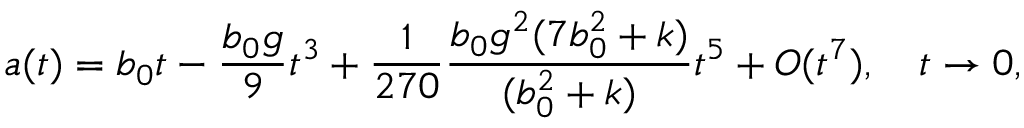<formula> <loc_0><loc_0><loc_500><loc_500>a ( t ) = b _ { 0 } t - \frac { b _ { 0 } g } { 9 } t ^ { 3 } + \frac { 1 } { 2 7 0 } \frac { b _ { 0 } g ^ { 2 } ( 7 b _ { 0 } ^ { 2 } + k ) } { ( b _ { 0 } ^ { 2 } + k ) } t ^ { 5 } + O ( t ^ { 7 } ) , \quad t \to 0 ,</formula> 